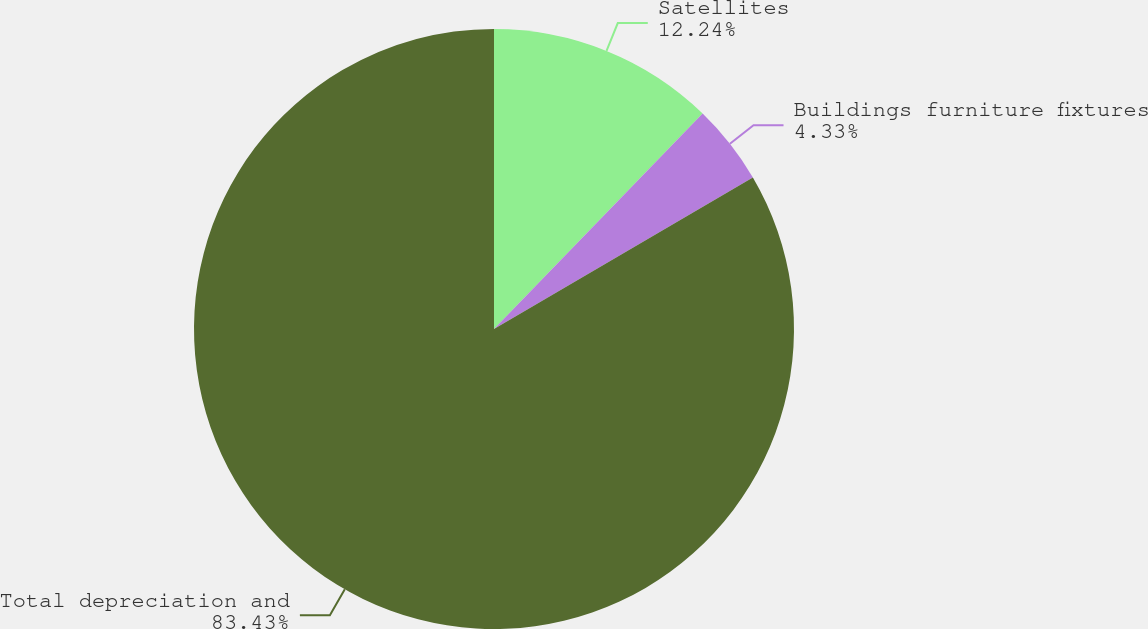Convert chart. <chart><loc_0><loc_0><loc_500><loc_500><pie_chart><fcel>Satellites<fcel>Buildings furniture fixtures<fcel>Total depreciation and<nl><fcel>12.24%<fcel>4.33%<fcel>83.44%<nl></chart> 